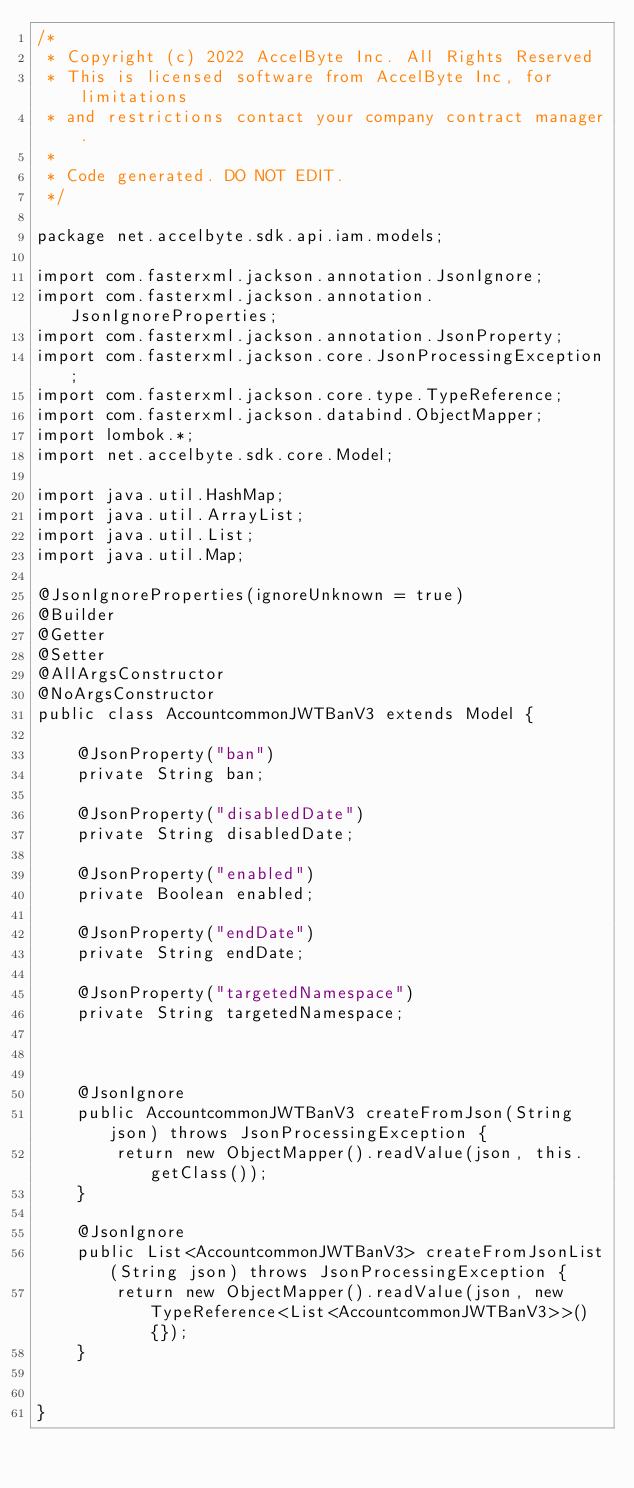Convert code to text. <code><loc_0><loc_0><loc_500><loc_500><_Java_>/*
 * Copyright (c) 2022 AccelByte Inc. All Rights Reserved
 * This is licensed software from AccelByte Inc, for limitations
 * and restrictions contact your company contract manager.
 *
 * Code generated. DO NOT EDIT.
 */

package net.accelbyte.sdk.api.iam.models;

import com.fasterxml.jackson.annotation.JsonIgnore;
import com.fasterxml.jackson.annotation.JsonIgnoreProperties;
import com.fasterxml.jackson.annotation.JsonProperty;
import com.fasterxml.jackson.core.JsonProcessingException;
import com.fasterxml.jackson.core.type.TypeReference;
import com.fasterxml.jackson.databind.ObjectMapper;
import lombok.*;
import net.accelbyte.sdk.core.Model;

import java.util.HashMap;
import java.util.ArrayList;
import java.util.List;
import java.util.Map;

@JsonIgnoreProperties(ignoreUnknown = true)
@Builder
@Getter
@Setter
@AllArgsConstructor
@NoArgsConstructor
public class AccountcommonJWTBanV3 extends Model {

    @JsonProperty("ban")
    private String ban;

    @JsonProperty("disabledDate")
    private String disabledDate;

    @JsonProperty("enabled")
    private Boolean enabled;

    @JsonProperty("endDate")
    private String endDate;

    @JsonProperty("targetedNamespace")
    private String targetedNamespace;



    @JsonIgnore
    public AccountcommonJWTBanV3 createFromJson(String json) throws JsonProcessingException {
        return new ObjectMapper().readValue(json, this.getClass());
    }

    @JsonIgnore
    public List<AccountcommonJWTBanV3> createFromJsonList(String json) throws JsonProcessingException {
        return new ObjectMapper().readValue(json, new TypeReference<List<AccountcommonJWTBanV3>>() {});
    }

    
}</code> 